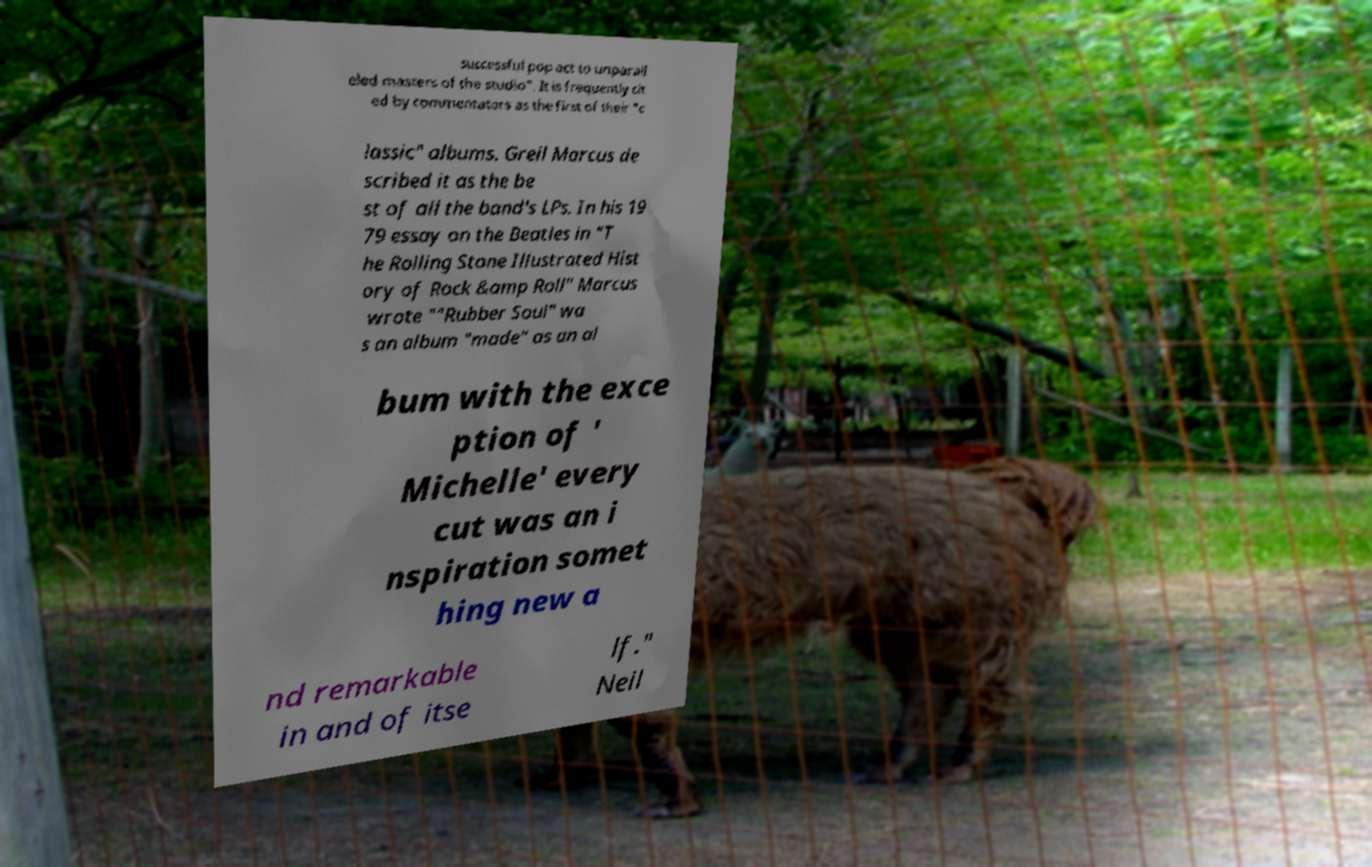Can you accurately transcribe the text from the provided image for me? successful pop act to unparall eled masters of the studio". It is frequently cit ed by commentators as the first of their "c lassic" albums. Greil Marcus de scribed it as the be st of all the band's LPs. In his 19 79 essay on the Beatles in "T he Rolling Stone Illustrated Hist ory of Rock &amp Roll" Marcus wrote ""Rubber Soul" wa s an album "made" as an al bum with the exce ption of ' Michelle' every cut was an i nspiration somet hing new a nd remarkable in and of itse lf." Neil 